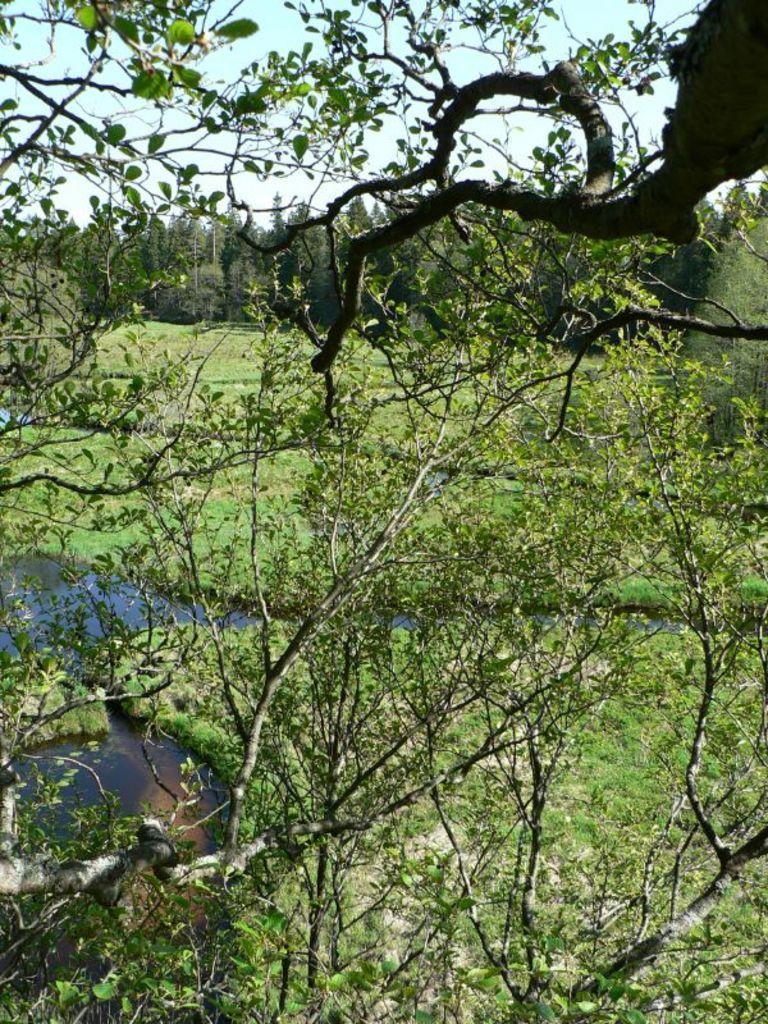How would you summarize this image in a sentence or two? In this image in the front there are leaves. In the background there is grass on the ground and there is water and there are trees. 